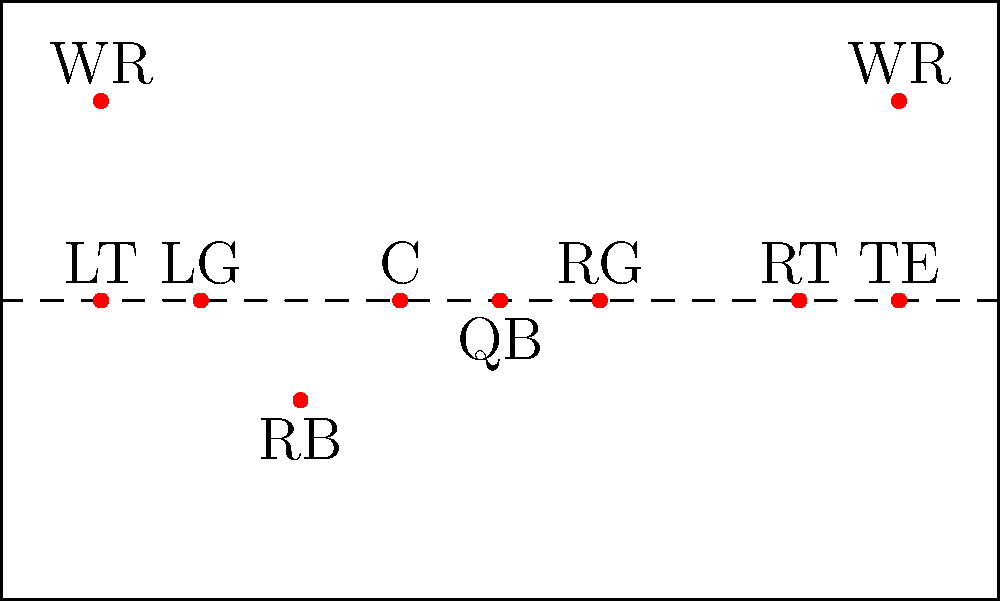In this offensive formation, which player is best positioned to provide additional pass protection for the quarterback against a strong-side blitz? To answer this question, let's analyze the offensive formation step-by-step:

1. Identify the strong side: The strong side is typically the side with the tight end (TE). In this formation, the TE is on the right side.

2. Understand blitz protection: Against a strong-side blitz, additional protection is often needed on the same side as the blitz is coming from.

3. Analyze player positions:
   - The offensive line (LT, LG, C, RG, RT) is already engaged in pass protection.
   - The wide receivers (WR) are typically downfield for passing routes.
   - The quarterback (QB) is the one needing protection.

4. Identify the most flexible position: The running back (RB) is positioned in the backfield and has the flexibility to move to either side for additional protection.

5. Consider the RB's role: In pass protection schemes, RBs are often responsible for picking up blitzing linebackers or defensive backs.

6. Evaluate the RB's position: The RB is already on the left side of the formation, making it easy to slide to the right (strong side) if needed for blitz protection.

Given these factors, the running back (RB) is best positioned to provide additional pass protection against a strong-side blitz. They can quickly move to the right side to pick up any extra rushers, helping to keep the quarterback safe.
Answer: Running Back (RB) 